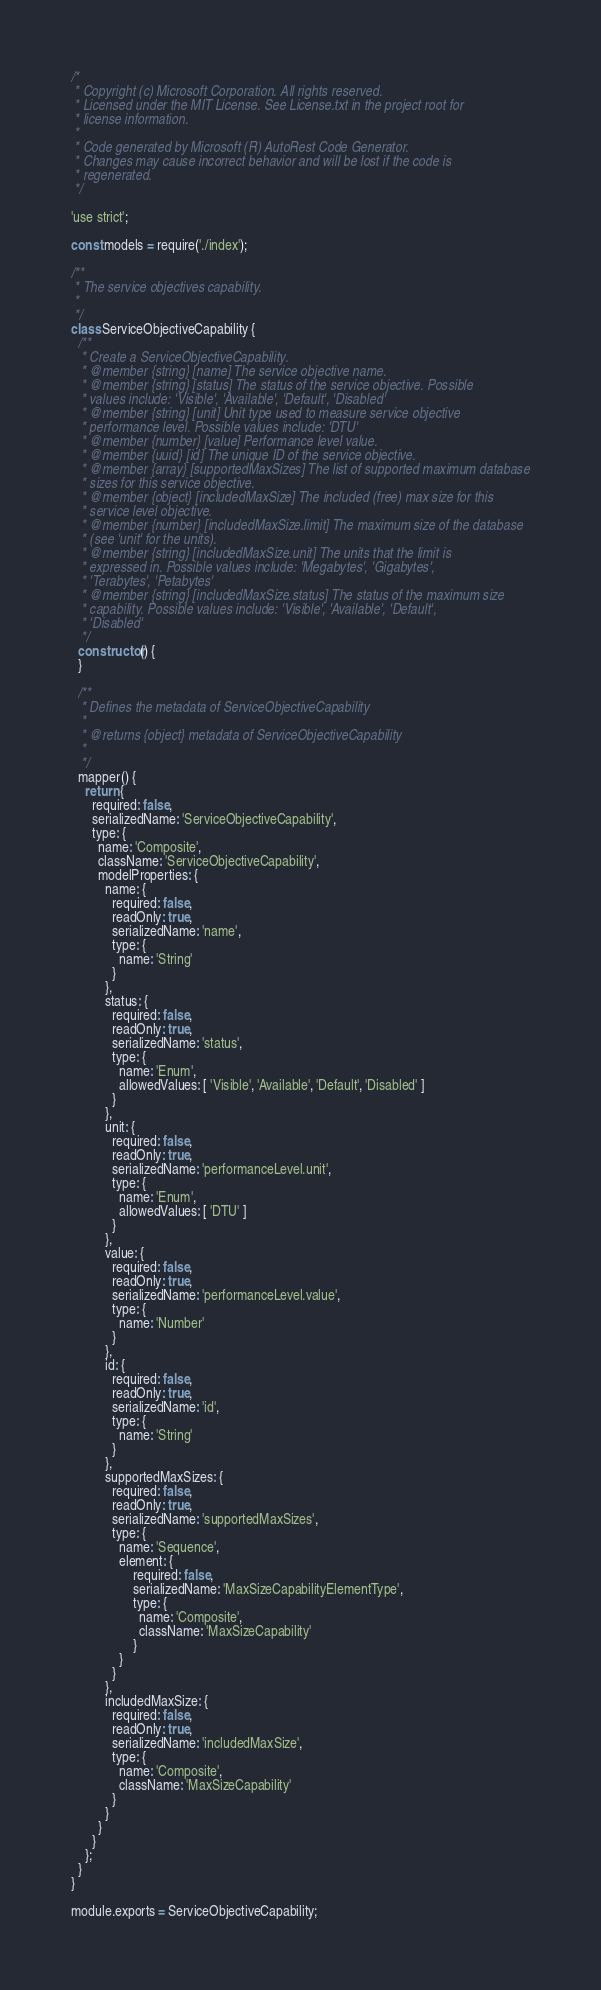<code> <loc_0><loc_0><loc_500><loc_500><_JavaScript_>/*
 * Copyright (c) Microsoft Corporation. All rights reserved.
 * Licensed under the MIT License. See License.txt in the project root for
 * license information.
 *
 * Code generated by Microsoft (R) AutoRest Code Generator.
 * Changes may cause incorrect behavior and will be lost if the code is
 * regenerated.
 */

'use strict';

const models = require('./index');

/**
 * The service objectives capability.
 *
 */
class ServiceObjectiveCapability {
  /**
   * Create a ServiceObjectiveCapability.
   * @member {string} [name] The service objective name.
   * @member {string} [status] The status of the service objective. Possible
   * values include: 'Visible', 'Available', 'Default', 'Disabled'
   * @member {string} [unit] Unit type used to measure service objective
   * performance level. Possible values include: 'DTU'
   * @member {number} [value] Performance level value.
   * @member {uuid} [id] The unique ID of the service objective.
   * @member {array} [supportedMaxSizes] The list of supported maximum database
   * sizes for this service objective.
   * @member {object} [includedMaxSize] The included (free) max size for this
   * service level objective.
   * @member {number} [includedMaxSize.limit] The maximum size of the database
   * (see 'unit' for the units).
   * @member {string} [includedMaxSize.unit] The units that the limit is
   * expressed in. Possible values include: 'Megabytes', 'Gigabytes',
   * 'Terabytes', 'Petabytes'
   * @member {string} [includedMaxSize.status] The status of the maximum size
   * capability. Possible values include: 'Visible', 'Available', 'Default',
   * 'Disabled'
   */
  constructor() {
  }

  /**
   * Defines the metadata of ServiceObjectiveCapability
   *
   * @returns {object} metadata of ServiceObjectiveCapability
   *
   */
  mapper() {
    return {
      required: false,
      serializedName: 'ServiceObjectiveCapability',
      type: {
        name: 'Composite',
        className: 'ServiceObjectiveCapability',
        modelProperties: {
          name: {
            required: false,
            readOnly: true,
            serializedName: 'name',
            type: {
              name: 'String'
            }
          },
          status: {
            required: false,
            readOnly: true,
            serializedName: 'status',
            type: {
              name: 'Enum',
              allowedValues: [ 'Visible', 'Available', 'Default', 'Disabled' ]
            }
          },
          unit: {
            required: false,
            readOnly: true,
            serializedName: 'performanceLevel.unit',
            type: {
              name: 'Enum',
              allowedValues: [ 'DTU' ]
            }
          },
          value: {
            required: false,
            readOnly: true,
            serializedName: 'performanceLevel.value',
            type: {
              name: 'Number'
            }
          },
          id: {
            required: false,
            readOnly: true,
            serializedName: 'id',
            type: {
              name: 'String'
            }
          },
          supportedMaxSizes: {
            required: false,
            readOnly: true,
            serializedName: 'supportedMaxSizes',
            type: {
              name: 'Sequence',
              element: {
                  required: false,
                  serializedName: 'MaxSizeCapabilityElementType',
                  type: {
                    name: 'Composite',
                    className: 'MaxSizeCapability'
                  }
              }
            }
          },
          includedMaxSize: {
            required: false,
            readOnly: true,
            serializedName: 'includedMaxSize',
            type: {
              name: 'Composite',
              className: 'MaxSizeCapability'
            }
          }
        }
      }
    };
  }
}

module.exports = ServiceObjectiveCapability;
</code> 